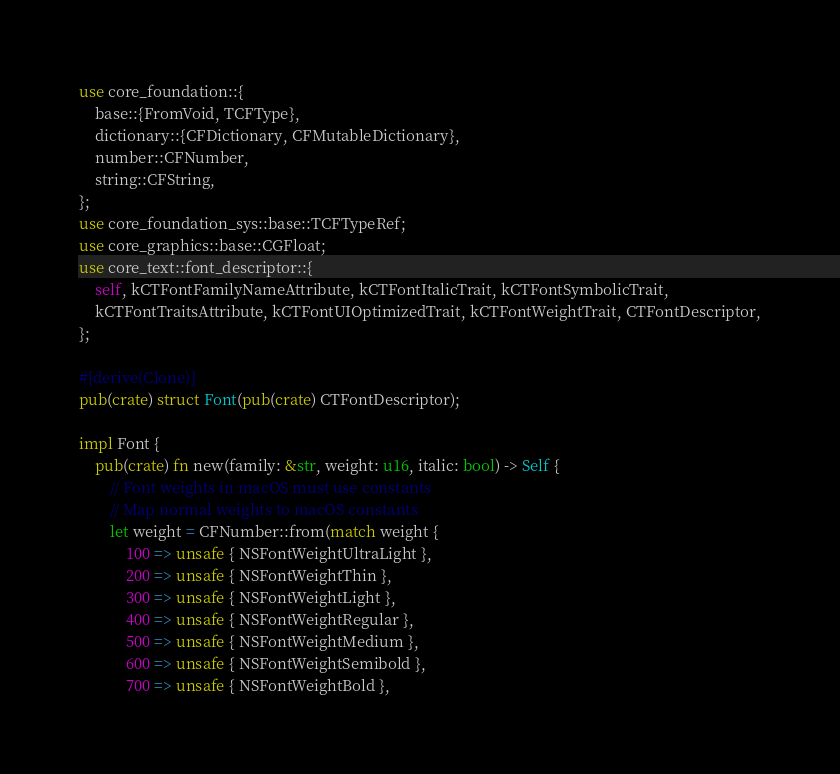Convert code to text. <code><loc_0><loc_0><loc_500><loc_500><_Rust_>use core_foundation::{
    base::{FromVoid, TCFType},
    dictionary::{CFDictionary, CFMutableDictionary},
    number::CFNumber,
    string::CFString,
};
use core_foundation_sys::base::TCFTypeRef;
use core_graphics::base::CGFloat;
use core_text::font_descriptor::{
    self, kCTFontFamilyNameAttribute, kCTFontItalicTrait, kCTFontSymbolicTrait,
    kCTFontTraitsAttribute, kCTFontUIOptimizedTrait, kCTFontWeightTrait, CTFontDescriptor,
};

#[derive(Clone)]
pub(crate) struct Font(pub(crate) CTFontDescriptor);

impl Font {
    pub(crate) fn new(family: &str, weight: u16, italic: bool) -> Self {
        // Font weights in macOS must use constants
        // Map normal weights to macOS constants
        let weight = CFNumber::from(match weight {
            100 => unsafe { NSFontWeightUltraLight },
            200 => unsafe { NSFontWeightThin },
            300 => unsafe { NSFontWeightLight },
            400 => unsafe { NSFontWeightRegular },
            500 => unsafe { NSFontWeightMedium },
            600 => unsafe { NSFontWeightSemibold },
            700 => unsafe { NSFontWeightBold },</code> 